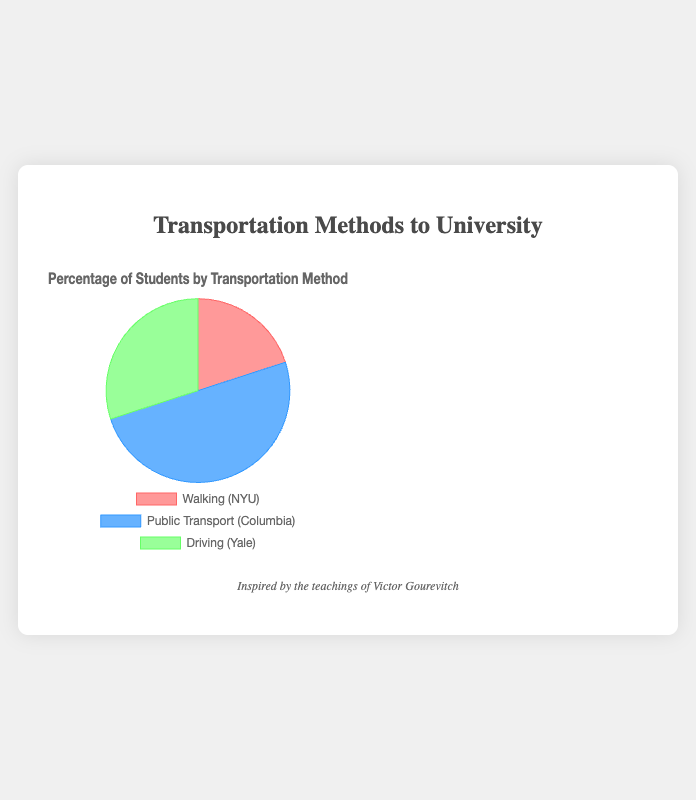Which transportation method has the highest percentage of students? To find the transportation method with the highest percentage, compare the given percentages: 20% for Walking, 50% for Public Transport, and 30% for Driving. Public Transport has the highest percentage at 50%.
Answer: Public Transport What is the combined percentage of students using Driving and Walking? Add the percentages of students using Driving and Walking: 30% (Driving) + 20% (Walking) = 50%.
Answer: 50% Which travel method is represented by the color blue in the pie chart? Observing the given colors in the chart, blue represents Public Transport.
Answer: Public Transport How much higher is the percentage of students using Public Transport compared to those Walking? Subtract the percentage of students walking from those using public transport: 50% (Public Transport) - 20% (Walking) = 30%.
Answer: 30% If 10% more students started Walking, how would the percentage change for Walking? Add the 10% increase to the current percentage of students walking: 20% + 10% = 30%.
Answer: 30% What is the average percentage of students using any transportation method? Add all the given percentages (20% + 50% + 30%) to get 100%, then divide by the number of transportation methods (3): 100% ÷ 3 = 33.33%.
Answer: 33.33% Which university uses Driving as a transportation method? Referring to the data points, Yale University is associated with Driving at 30%.
Answer: Yale University Is the percentage of students using Public Transport more than twice the percentage of those Walking? Multiply the percentage of students Walking by 2: 20% × 2 = 40%. Since 50% (Public Transport) is greater than 40%, the answer is yes.
Answer: Yes What's the difference in percentage between the method with the lowest and the highest student usage? Subtract the lowest percentage (Walking, 20%) from the highest percentage (Public Transport, 50%): 50% - 20% = 30%.
Answer: 30% Rank the transportation methods from highest to lowest percentage of student usage. Based on the given percentages: 50% (Public Transport) > 30% (Driving) > 20% (Walking).
Answer: Public Transport, Driving, Walking 